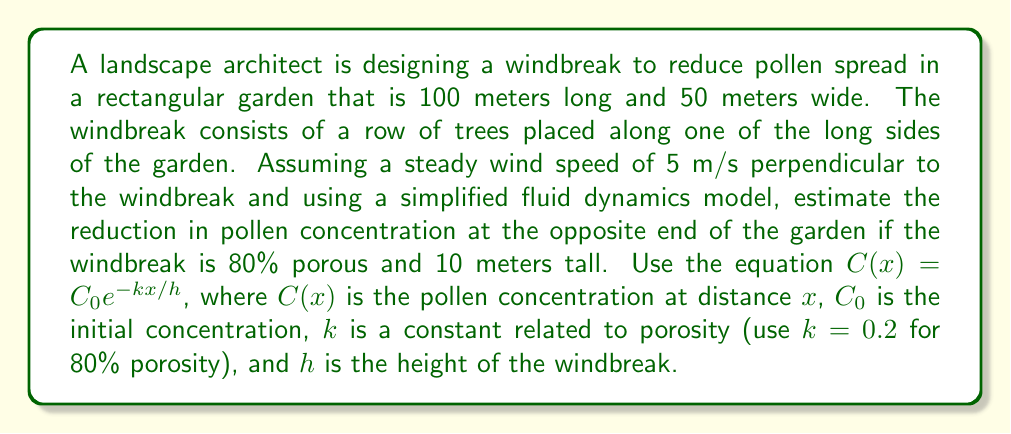Solve this math problem. To solve this problem, we'll follow these steps:

1) Identify the given information:
   - Garden dimensions: 100 m x 50 m
   - Windbreak height (h): 10 m
   - Windbreak porosity: 80% (k = 0.2)
   - Distance (x): 50 m (width of the garden)
   - Equation: $C(x) = C_0 e^{-kx/h}$

2) Substitute the values into the equation:
   $$C(50) = C_0 e^{-0.2 \cdot 50 / 10}$$

3) Simplify the exponent:
   $$C(50) = C_0 e^{-1}$$

4) Calculate the value of $e^{-1}$:
   $$C(50) = C_0 \cdot 0.3679$$

5) Express the result as a percentage of the initial concentration:
   $$\frac{C(50)}{C_0} = 0.3679 = 36.79\%$$

6) Calculate the reduction in pollen concentration:
   Reduction = 100% - 36.79% = 63.21%

The pollen concentration at the opposite end of the garden is reduced to 36.79% of its initial value, which means a reduction of 63.21%.
Answer: 63.21% reduction in pollen concentration 